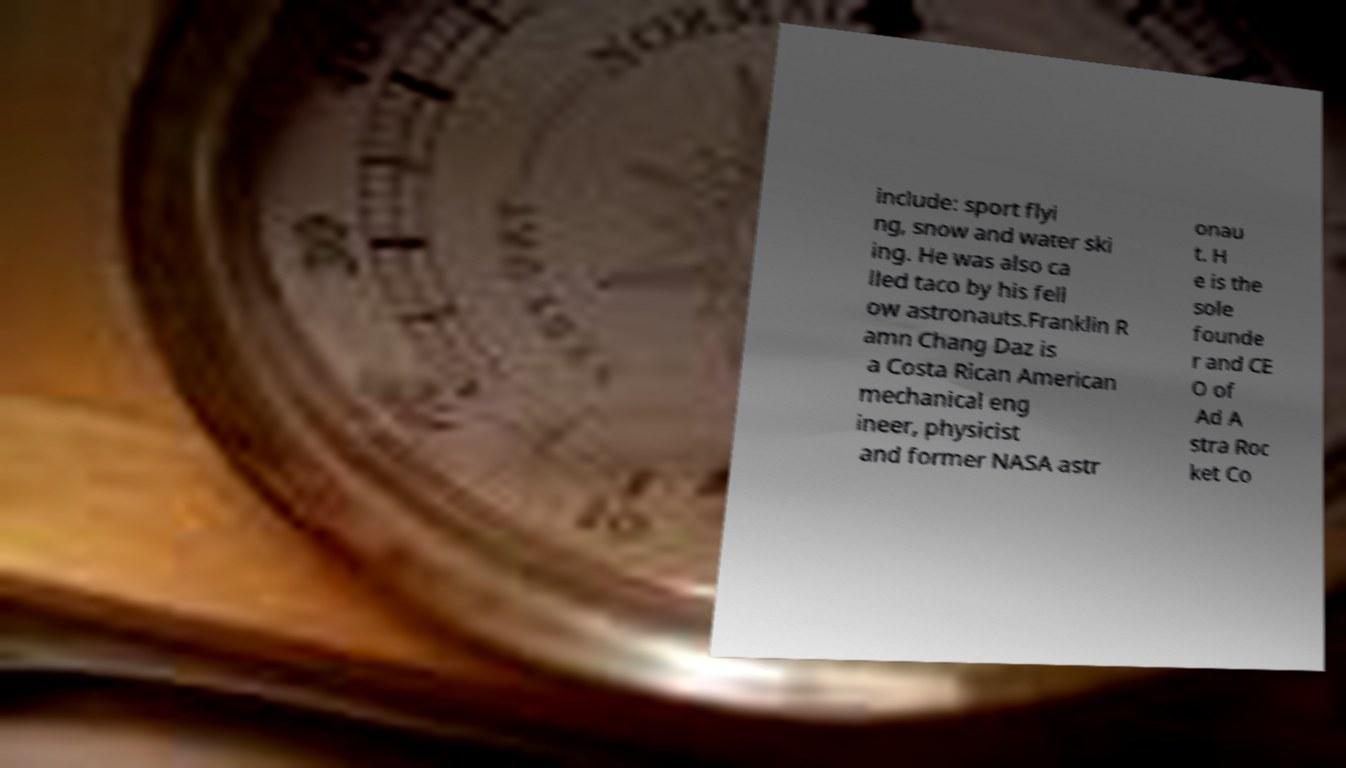There's text embedded in this image that I need extracted. Can you transcribe it verbatim? include: sport flyi ng, snow and water ski ing. He was also ca lled taco by his fell ow astronauts.Franklin R amn Chang Daz is a Costa Rican American mechanical eng ineer, physicist and former NASA astr onau t. H e is the sole founde r and CE O of Ad A stra Roc ket Co 